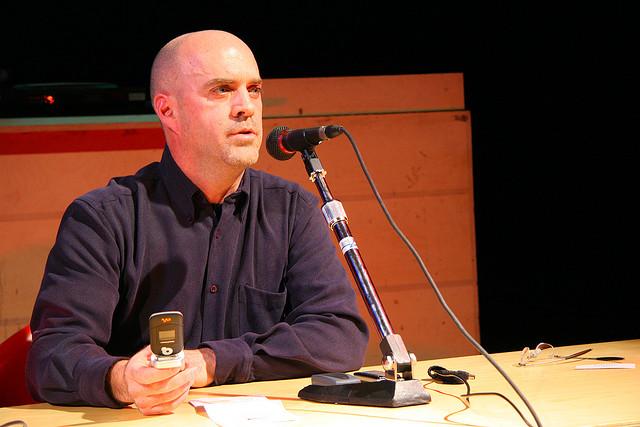Is the Mike set at a good level for speaking?
Keep it brief. Yes. What device is in his hand?
Quick response, please. Phone. Is he giving a speech?
Short answer required. Yes. 